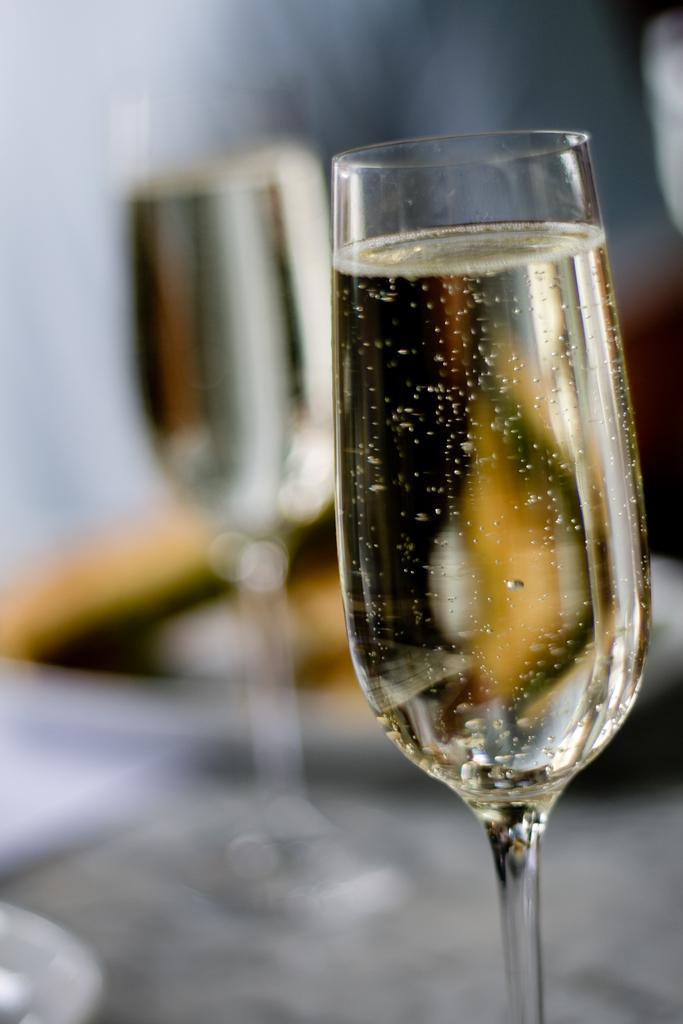What objects are present in the image related to drinking? There are two wine glasses in the image. Where are the wine glasses located? The wine glasses are placed on a table. What type of wire is used to hold the eggs in the image? There are no eggs or wire present in the image; it only features two wine glasses on a table. 